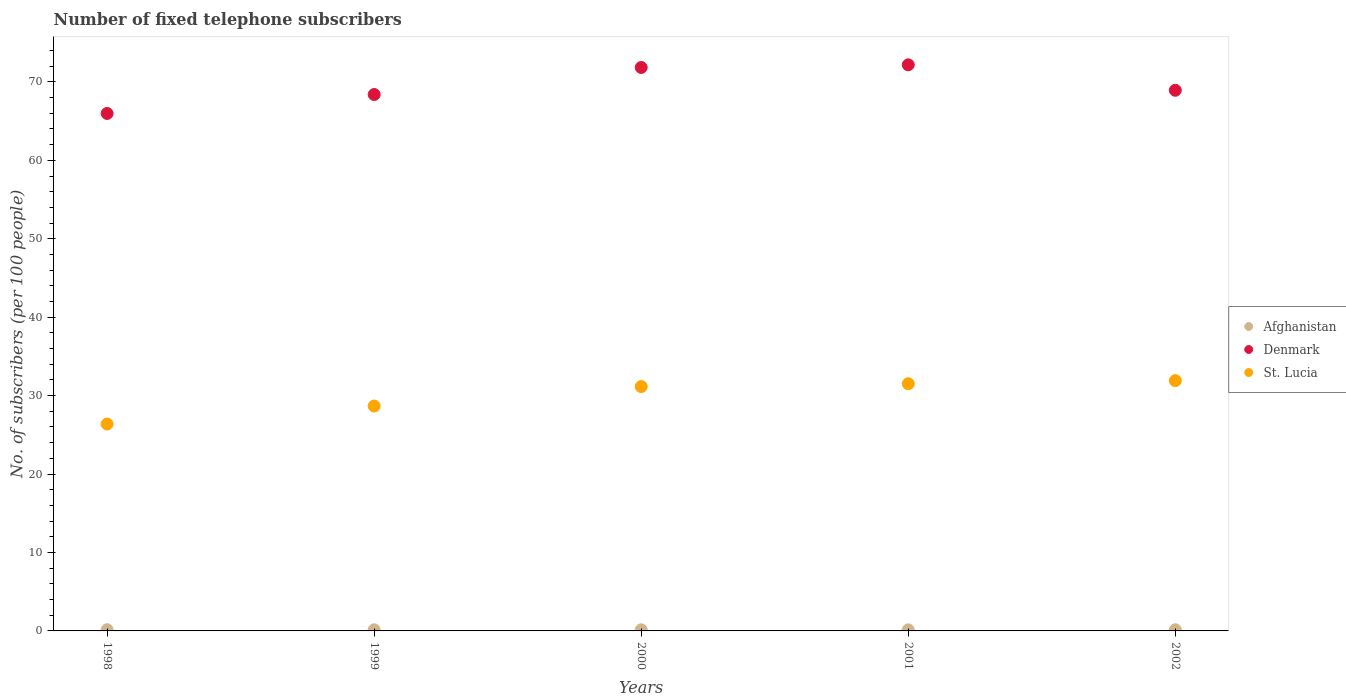How many different coloured dotlines are there?
Offer a very short reply. 3. Is the number of dotlines equal to the number of legend labels?
Provide a short and direct response. Yes. What is the number of fixed telephone subscribers in St. Lucia in 1998?
Make the answer very short. 26.38. Across all years, what is the maximum number of fixed telephone subscribers in Afghanistan?
Provide a short and direct response. 0.15. Across all years, what is the minimum number of fixed telephone subscribers in Afghanistan?
Your response must be concise. 0.14. What is the total number of fixed telephone subscribers in St. Lucia in the graph?
Offer a terse response. 149.63. What is the difference between the number of fixed telephone subscribers in Denmark in 1998 and that in 2000?
Keep it short and to the point. -5.86. What is the difference between the number of fixed telephone subscribers in Afghanistan in 1998 and the number of fixed telephone subscribers in St. Lucia in 2002?
Your answer should be very brief. -31.76. What is the average number of fixed telephone subscribers in Afghanistan per year?
Your response must be concise. 0.14. In the year 1998, what is the difference between the number of fixed telephone subscribers in St. Lucia and number of fixed telephone subscribers in Afghanistan?
Offer a terse response. 26.23. In how many years, is the number of fixed telephone subscribers in Denmark greater than 50?
Your answer should be compact. 5. What is the ratio of the number of fixed telephone subscribers in St. Lucia in 1999 to that in 2000?
Provide a short and direct response. 0.92. Is the difference between the number of fixed telephone subscribers in St. Lucia in 1998 and 2001 greater than the difference between the number of fixed telephone subscribers in Afghanistan in 1998 and 2001?
Offer a terse response. No. What is the difference between the highest and the second highest number of fixed telephone subscribers in Afghanistan?
Provide a short and direct response. 0. What is the difference between the highest and the lowest number of fixed telephone subscribers in St. Lucia?
Keep it short and to the point. 5.53. Is the sum of the number of fixed telephone subscribers in Denmark in 1998 and 2000 greater than the maximum number of fixed telephone subscribers in Afghanistan across all years?
Offer a very short reply. Yes. Does the number of fixed telephone subscribers in St. Lucia monotonically increase over the years?
Make the answer very short. Yes. What is the difference between two consecutive major ticks on the Y-axis?
Offer a terse response. 10. Does the graph contain grids?
Provide a short and direct response. No. What is the title of the graph?
Make the answer very short. Number of fixed telephone subscribers. Does "Jamaica" appear as one of the legend labels in the graph?
Your response must be concise. No. What is the label or title of the Y-axis?
Your answer should be very brief. No. of subscribers (per 100 people). What is the No. of subscribers (per 100 people) of Afghanistan in 1998?
Your answer should be very brief. 0.15. What is the No. of subscribers (per 100 people) in Denmark in 1998?
Give a very brief answer. 65.98. What is the No. of subscribers (per 100 people) of St. Lucia in 1998?
Offer a terse response. 26.38. What is the No. of subscribers (per 100 people) of Afghanistan in 1999?
Your answer should be very brief. 0.15. What is the No. of subscribers (per 100 people) of Denmark in 1999?
Offer a very short reply. 68.39. What is the No. of subscribers (per 100 people) in St. Lucia in 1999?
Provide a short and direct response. 28.67. What is the No. of subscribers (per 100 people) in Afghanistan in 2000?
Provide a short and direct response. 0.14. What is the No. of subscribers (per 100 people) of Denmark in 2000?
Make the answer very short. 71.84. What is the No. of subscribers (per 100 people) in St. Lucia in 2000?
Your response must be concise. 31.16. What is the No. of subscribers (per 100 people) in Afghanistan in 2001?
Your response must be concise. 0.14. What is the No. of subscribers (per 100 people) in Denmark in 2001?
Your answer should be compact. 72.18. What is the No. of subscribers (per 100 people) in St. Lucia in 2001?
Give a very brief answer. 31.52. What is the No. of subscribers (per 100 people) in Afghanistan in 2002?
Your answer should be compact. 0.15. What is the No. of subscribers (per 100 people) in Denmark in 2002?
Offer a terse response. 68.93. What is the No. of subscribers (per 100 people) in St. Lucia in 2002?
Make the answer very short. 31.91. Across all years, what is the maximum No. of subscribers (per 100 people) of Afghanistan?
Your response must be concise. 0.15. Across all years, what is the maximum No. of subscribers (per 100 people) in Denmark?
Ensure brevity in your answer.  72.18. Across all years, what is the maximum No. of subscribers (per 100 people) of St. Lucia?
Your answer should be very brief. 31.91. Across all years, what is the minimum No. of subscribers (per 100 people) in Afghanistan?
Ensure brevity in your answer.  0.14. Across all years, what is the minimum No. of subscribers (per 100 people) of Denmark?
Offer a terse response. 65.98. Across all years, what is the minimum No. of subscribers (per 100 people) in St. Lucia?
Offer a very short reply. 26.38. What is the total No. of subscribers (per 100 people) in Afghanistan in the graph?
Make the answer very short. 0.72. What is the total No. of subscribers (per 100 people) in Denmark in the graph?
Your answer should be very brief. 347.32. What is the total No. of subscribers (per 100 people) in St. Lucia in the graph?
Your response must be concise. 149.63. What is the difference between the No. of subscribers (per 100 people) in Afghanistan in 1998 and that in 1999?
Keep it short and to the point. 0. What is the difference between the No. of subscribers (per 100 people) in Denmark in 1998 and that in 1999?
Make the answer very short. -2.42. What is the difference between the No. of subscribers (per 100 people) in St. Lucia in 1998 and that in 1999?
Offer a very short reply. -2.3. What is the difference between the No. of subscribers (per 100 people) of Afghanistan in 1998 and that in 2000?
Your answer should be compact. 0.01. What is the difference between the No. of subscribers (per 100 people) of Denmark in 1998 and that in 2000?
Your answer should be very brief. -5.86. What is the difference between the No. of subscribers (per 100 people) in St. Lucia in 1998 and that in 2000?
Keep it short and to the point. -4.78. What is the difference between the No. of subscribers (per 100 people) in Afghanistan in 1998 and that in 2001?
Keep it short and to the point. 0.01. What is the difference between the No. of subscribers (per 100 people) in Denmark in 1998 and that in 2001?
Give a very brief answer. -6.2. What is the difference between the No. of subscribers (per 100 people) in St. Lucia in 1998 and that in 2001?
Your answer should be compact. -5.14. What is the difference between the No. of subscribers (per 100 people) of Afghanistan in 1998 and that in 2002?
Provide a succinct answer. -0. What is the difference between the No. of subscribers (per 100 people) of Denmark in 1998 and that in 2002?
Ensure brevity in your answer.  -2.95. What is the difference between the No. of subscribers (per 100 people) of St. Lucia in 1998 and that in 2002?
Make the answer very short. -5.53. What is the difference between the No. of subscribers (per 100 people) of Afghanistan in 1999 and that in 2000?
Offer a terse response. 0. What is the difference between the No. of subscribers (per 100 people) of Denmark in 1999 and that in 2000?
Offer a very short reply. -3.45. What is the difference between the No. of subscribers (per 100 people) of St. Lucia in 1999 and that in 2000?
Ensure brevity in your answer.  -2.48. What is the difference between the No. of subscribers (per 100 people) of Afghanistan in 1999 and that in 2001?
Offer a terse response. 0.01. What is the difference between the No. of subscribers (per 100 people) of Denmark in 1999 and that in 2001?
Offer a very short reply. -3.78. What is the difference between the No. of subscribers (per 100 people) in St. Lucia in 1999 and that in 2001?
Provide a short and direct response. -2.84. What is the difference between the No. of subscribers (per 100 people) in Afghanistan in 1999 and that in 2002?
Provide a succinct answer. -0. What is the difference between the No. of subscribers (per 100 people) of Denmark in 1999 and that in 2002?
Ensure brevity in your answer.  -0.54. What is the difference between the No. of subscribers (per 100 people) in St. Lucia in 1999 and that in 2002?
Your answer should be very brief. -3.23. What is the difference between the No. of subscribers (per 100 people) of Afghanistan in 2000 and that in 2001?
Ensure brevity in your answer.  0.01. What is the difference between the No. of subscribers (per 100 people) of Denmark in 2000 and that in 2001?
Offer a terse response. -0.34. What is the difference between the No. of subscribers (per 100 people) of St. Lucia in 2000 and that in 2001?
Offer a terse response. -0.36. What is the difference between the No. of subscribers (per 100 people) in Afghanistan in 2000 and that in 2002?
Ensure brevity in your answer.  -0.01. What is the difference between the No. of subscribers (per 100 people) in Denmark in 2000 and that in 2002?
Make the answer very short. 2.91. What is the difference between the No. of subscribers (per 100 people) of St. Lucia in 2000 and that in 2002?
Keep it short and to the point. -0.75. What is the difference between the No. of subscribers (per 100 people) of Afghanistan in 2001 and that in 2002?
Make the answer very short. -0.01. What is the difference between the No. of subscribers (per 100 people) of Denmark in 2001 and that in 2002?
Your answer should be very brief. 3.25. What is the difference between the No. of subscribers (per 100 people) of St. Lucia in 2001 and that in 2002?
Offer a terse response. -0.39. What is the difference between the No. of subscribers (per 100 people) of Afghanistan in 1998 and the No. of subscribers (per 100 people) of Denmark in 1999?
Provide a succinct answer. -68.24. What is the difference between the No. of subscribers (per 100 people) of Afghanistan in 1998 and the No. of subscribers (per 100 people) of St. Lucia in 1999?
Your answer should be compact. -28.52. What is the difference between the No. of subscribers (per 100 people) in Denmark in 1998 and the No. of subscribers (per 100 people) in St. Lucia in 1999?
Your answer should be compact. 37.3. What is the difference between the No. of subscribers (per 100 people) in Afghanistan in 1998 and the No. of subscribers (per 100 people) in Denmark in 2000?
Provide a succinct answer. -71.69. What is the difference between the No. of subscribers (per 100 people) of Afghanistan in 1998 and the No. of subscribers (per 100 people) of St. Lucia in 2000?
Ensure brevity in your answer.  -31.01. What is the difference between the No. of subscribers (per 100 people) of Denmark in 1998 and the No. of subscribers (per 100 people) of St. Lucia in 2000?
Keep it short and to the point. 34.82. What is the difference between the No. of subscribers (per 100 people) in Afghanistan in 1998 and the No. of subscribers (per 100 people) in Denmark in 2001?
Give a very brief answer. -72.03. What is the difference between the No. of subscribers (per 100 people) of Afghanistan in 1998 and the No. of subscribers (per 100 people) of St. Lucia in 2001?
Provide a short and direct response. -31.37. What is the difference between the No. of subscribers (per 100 people) in Denmark in 1998 and the No. of subscribers (per 100 people) in St. Lucia in 2001?
Give a very brief answer. 34.46. What is the difference between the No. of subscribers (per 100 people) in Afghanistan in 1998 and the No. of subscribers (per 100 people) in Denmark in 2002?
Make the answer very short. -68.78. What is the difference between the No. of subscribers (per 100 people) of Afghanistan in 1998 and the No. of subscribers (per 100 people) of St. Lucia in 2002?
Provide a succinct answer. -31.76. What is the difference between the No. of subscribers (per 100 people) of Denmark in 1998 and the No. of subscribers (per 100 people) of St. Lucia in 2002?
Give a very brief answer. 34.07. What is the difference between the No. of subscribers (per 100 people) of Afghanistan in 1999 and the No. of subscribers (per 100 people) of Denmark in 2000?
Your response must be concise. -71.69. What is the difference between the No. of subscribers (per 100 people) of Afghanistan in 1999 and the No. of subscribers (per 100 people) of St. Lucia in 2000?
Offer a very short reply. -31.01. What is the difference between the No. of subscribers (per 100 people) in Denmark in 1999 and the No. of subscribers (per 100 people) in St. Lucia in 2000?
Ensure brevity in your answer.  37.24. What is the difference between the No. of subscribers (per 100 people) of Afghanistan in 1999 and the No. of subscribers (per 100 people) of Denmark in 2001?
Offer a terse response. -72.03. What is the difference between the No. of subscribers (per 100 people) in Afghanistan in 1999 and the No. of subscribers (per 100 people) in St. Lucia in 2001?
Offer a terse response. -31.37. What is the difference between the No. of subscribers (per 100 people) in Denmark in 1999 and the No. of subscribers (per 100 people) in St. Lucia in 2001?
Ensure brevity in your answer.  36.88. What is the difference between the No. of subscribers (per 100 people) in Afghanistan in 1999 and the No. of subscribers (per 100 people) in Denmark in 2002?
Offer a very short reply. -68.79. What is the difference between the No. of subscribers (per 100 people) in Afghanistan in 1999 and the No. of subscribers (per 100 people) in St. Lucia in 2002?
Your answer should be very brief. -31.76. What is the difference between the No. of subscribers (per 100 people) in Denmark in 1999 and the No. of subscribers (per 100 people) in St. Lucia in 2002?
Keep it short and to the point. 36.49. What is the difference between the No. of subscribers (per 100 people) of Afghanistan in 2000 and the No. of subscribers (per 100 people) of Denmark in 2001?
Offer a very short reply. -72.04. What is the difference between the No. of subscribers (per 100 people) of Afghanistan in 2000 and the No. of subscribers (per 100 people) of St. Lucia in 2001?
Your answer should be very brief. -31.38. What is the difference between the No. of subscribers (per 100 people) of Denmark in 2000 and the No. of subscribers (per 100 people) of St. Lucia in 2001?
Provide a succinct answer. 40.32. What is the difference between the No. of subscribers (per 100 people) of Afghanistan in 2000 and the No. of subscribers (per 100 people) of Denmark in 2002?
Provide a short and direct response. -68.79. What is the difference between the No. of subscribers (per 100 people) in Afghanistan in 2000 and the No. of subscribers (per 100 people) in St. Lucia in 2002?
Provide a short and direct response. -31.77. What is the difference between the No. of subscribers (per 100 people) of Denmark in 2000 and the No. of subscribers (per 100 people) of St. Lucia in 2002?
Give a very brief answer. 39.93. What is the difference between the No. of subscribers (per 100 people) in Afghanistan in 2001 and the No. of subscribers (per 100 people) in Denmark in 2002?
Offer a terse response. -68.79. What is the difference between the No. of subscribers (per 100 people) in Afghanistan in 2001 and the No. of subscribers (per 100 people) in St. Lucia in 2002?
Give a very brief answer. -31.77. What is the difference between the No. of subscribers (per 100 people) of Denmark in 2001 and the No. of subscribers (per 100 people) of St. Lucia in 2002?
Offer a very short reply. 40.27. What is the average No. of subscribers (per 100 people) of Afghanistan per year?
Offer a very short reply. 0.14. What is the average No. of subscribers (per 100 people) of Denmark per year?
Your response must be concise. 69.46. What is the average No. of subscribers (per 100 people) of St. Lucia per year?
Provide a short and direct response. 29.93. In the year 1998, what is the difference between the No. of subscribers (per 100 people) of Afghanistan and No. of subscribers (per 100 people) of Denmark?
Give a very brief answer. -65.83. In the year 1998, what is the difference between the No. of subscribers (per 100 people) in Afghanistan and No. of subscribers (per 100 people) in St. Lucia?
Keep it short and to the point. -26.23. In the year 1998, what is the difference between the No. of subscribers (per 100 people) in Denmark and No. of subscribers (per 100 people) in St. Lucia?
Ensure brevity in your answer.  39.6. In the year 1999, what is the difference between the No. of subscribers (per 100 people) in Afghanistan and No. of subscribers (per 100 people) in Denmark?
Your response must be concise. -68.25. In the year 1999, what is the difference between the No. of subscribers (per 100 people) of Afghanistan and No. of subscribers (per 100 people) of St. Lucia?
Give a very brief answer. -28.53. In the year 1999, what is the difference between the No. of subscribers (per 100 people) of Denmark and No. of subscribers (per 100 people) of St. Lucia?
Make the answer very short. 39.72. In the year 2000, what is the difference between the No. of subscribers (per 100 people) of Afghanistan and No. of subscribers (per 100 people) of Denmark?
Your response must be concise. -71.7. In the year 2000, what is the difference between the No. of subscribers (per 100 people) of Afghanistan and No. of subscribers (per 100 people) of St. Lucia?
Your response must be concise. -31.02. In the year 2000, what is the difference between the No. of subscribers (per 100 people) in Denmark and No. of subscribers (per 100 people) in St. Lucia?
Offer a very short reply. 40.68. In the year 2001, what is the difference between the No. of subscribers (per 100 people) of Afghanistan and No. of subscribers (per 100 people) of Denmark?
Provide a succinct answer. -72.04. In the year 2001, what is the difference between the No. of subscribers (per 100 people) in Afghanistan and No. of subscribers (per 100 people) in St. Lucia?
Your answer should be very brief. -31.38. In the year 2001, what is the difference between the No. of subscribers (per 100 people) of Denmark and No. of subscribers (per 100 people) of St. Lucia?
Your response must be concise. 40.66. In the year 2002, what is the difference between the No. of subscribers (per 100 people) of Afghanistan and No. of subscribers (per 100 people) of Denmark?
Give a very brief answer. -68.78. In the year 2002, what is the difference between the No. of subscribers (per 100 people) of Afghanistan and No. of subscribers (per 100 people) of St. Lucia?
Make the answer very short. -31.76. In the year 2002, what is the difference between the No. of subscribers (per 100 people) of Denmark and No. of subscribers (per 100 people) of St. Lucia?
Give a very brief answer. 37.02. What is the ratio of the No. of subscribers (per 100 people) in Afghanistan in 1998 to that in 1999?
Your response must be concise. 1.03. What is the ratio of the No. of subscribers (per 100 people) of Denmark in 1998 to that in 1999?
Offer a terse response. 0.96. What is the ratio of the No. of subscribers (per 100 people) in St. Lucia in 1998 to that in 1999?
Your response must be concise. 0.92. What is the ratio of the No. of subscribers (per 100 people) in Afghanistan in 1998 to that in 2000?
Make the answer very short. 1.06. What is the ratio of the No. of subscribers (per 100 people) in Denmark in 1998 to that in 2000?
Keep it short and to the point. 0.92. What is the ratio of the No. of subscribers (per 100 people) of St. Lucia in 1998 to that in 2000?
Offer a very short reply. 0.85. What is the ratio of the No. of subscribers (per 100 people) in Afghanistan in 1998 to that in 2001?
Offer a very short reply. 1.09. What is the ratio of the No. of subscribers (per 100 people) of Denmark in 1998 to that in 2001?
Give a very brief answer. 0.91. What is the ratio of the No. of subscribers (per 100 people) of St. Lucia in 1998 to that in 2001?
Your answer should be compact. 0.84. What is the ratio of the No. of subscribers (per 100 people) of Denmark in 1998 to that in 2002?
Offer a very short reply. 0.96. What is the ratio of the No. of subscribers (per 100 people) in St. Lucia in 1998 to that in 2002?
Your answer should be compact. 0.83. What is the ratio of the No. of subscribers (per 100 people) in Afghanistan in 1999 to that in 2000?
Provide a short and direct response. 1.03. What is the ratio of the No. of subscribers (per 100 people) in St. Lucia in 1999 to that in 2000?
Offer a very short reply. 0.92. What is the ratio of the No. of subscribers (per 100 people) in Afghanistan in 1999 to that in 2001?
Offer a very short reply. 1.07. What is the ratio of the No. of subscribers (per 100 people) of Denmark in 1999 to that in 2001?
Your answer should be compact. 0.95. What is the ratio of the No. of subscribers (per 100 people) of St. Lucia in 1999 to that in 2001?
Your answer should be compact. 0.91. What is the ratio of the No. of subscribers (per 100 people) in Afghanistan in 1999 to that in 2002?
Give a very brief answer. 0.97. What is the ratio of the No. of subscribers (per 100 people) in Denmark in 1999 to that in 2002?
Offer a terse response. 0.99. What is the ratio of the No. of subscribers (per 100 people) in St. Lucia in 1999 to that in 2002?
Provide a succinct answer. 0.9. What is the ratio of the No. of subscribers (per 100 people) of Afghanistan in 2000 to that in 2001?
Your answer should be very brief. 1.04. What is the ratio of the No. of subscribers (per 100 people) in St. Lucia in 2000 to that in 2001?
Offer a terse response. 0.99. What is the ratio of the No. of subscribers (per 100 people) in Afghanistan in 2000 to that in 2002?
Your answer should be very brief. 0.95. What is the ratio of the No. of subscribers (per 100 people) in Denmark in 2000 to that in 2002?
Make the answer very short. 1.04. What is the ratio of the No. of subscribers (per 100 people) in St. Lucia in 2000 to that in 2002?
Keep it short and to the point. 0.98. What is the ratio of the No. of subscribers (per 100 people) of Afghanistan in 2001 to that in 2002?
Your answer should be compact. 0.91. What is the ratio of the No. of subscribers (per 100 people) in Denmark in 2001 to that in 2002?
Provide a succinct answer. 1.05. What is the ratio of the No. of subscribers (per 100 people) of St. Lucia in 2001 to that in 2002?
Offer a terse response. 0.99. What is the difference between the highest and the second highest No. of subscribers (per 100 people) of Afghanistan?
Offer a very short reply. 0. What is the difference between the highest and the second highest No. of subscribers (per 100 people) in Denmark?
Your response must be concise. 0.34. What is the difference between the highest and the second highest No. of subscribers (per 100 people) in St. Lucia?
Offer a terse response. 0.39. What is the difference between the highest and the lowest No. of subscribers (per 100 people) in Afghanistan?
Your response must be concise. 0.01. What is the difference between the highest and the lowest No. of subscribers (per 100 people) in Denmark?
Make the answer very short. 6.2. What is the difference between the highest and the lowest No. of subscribers (per 100 people) of St. Lucia?
Provide a succinct answer. 5.53. 